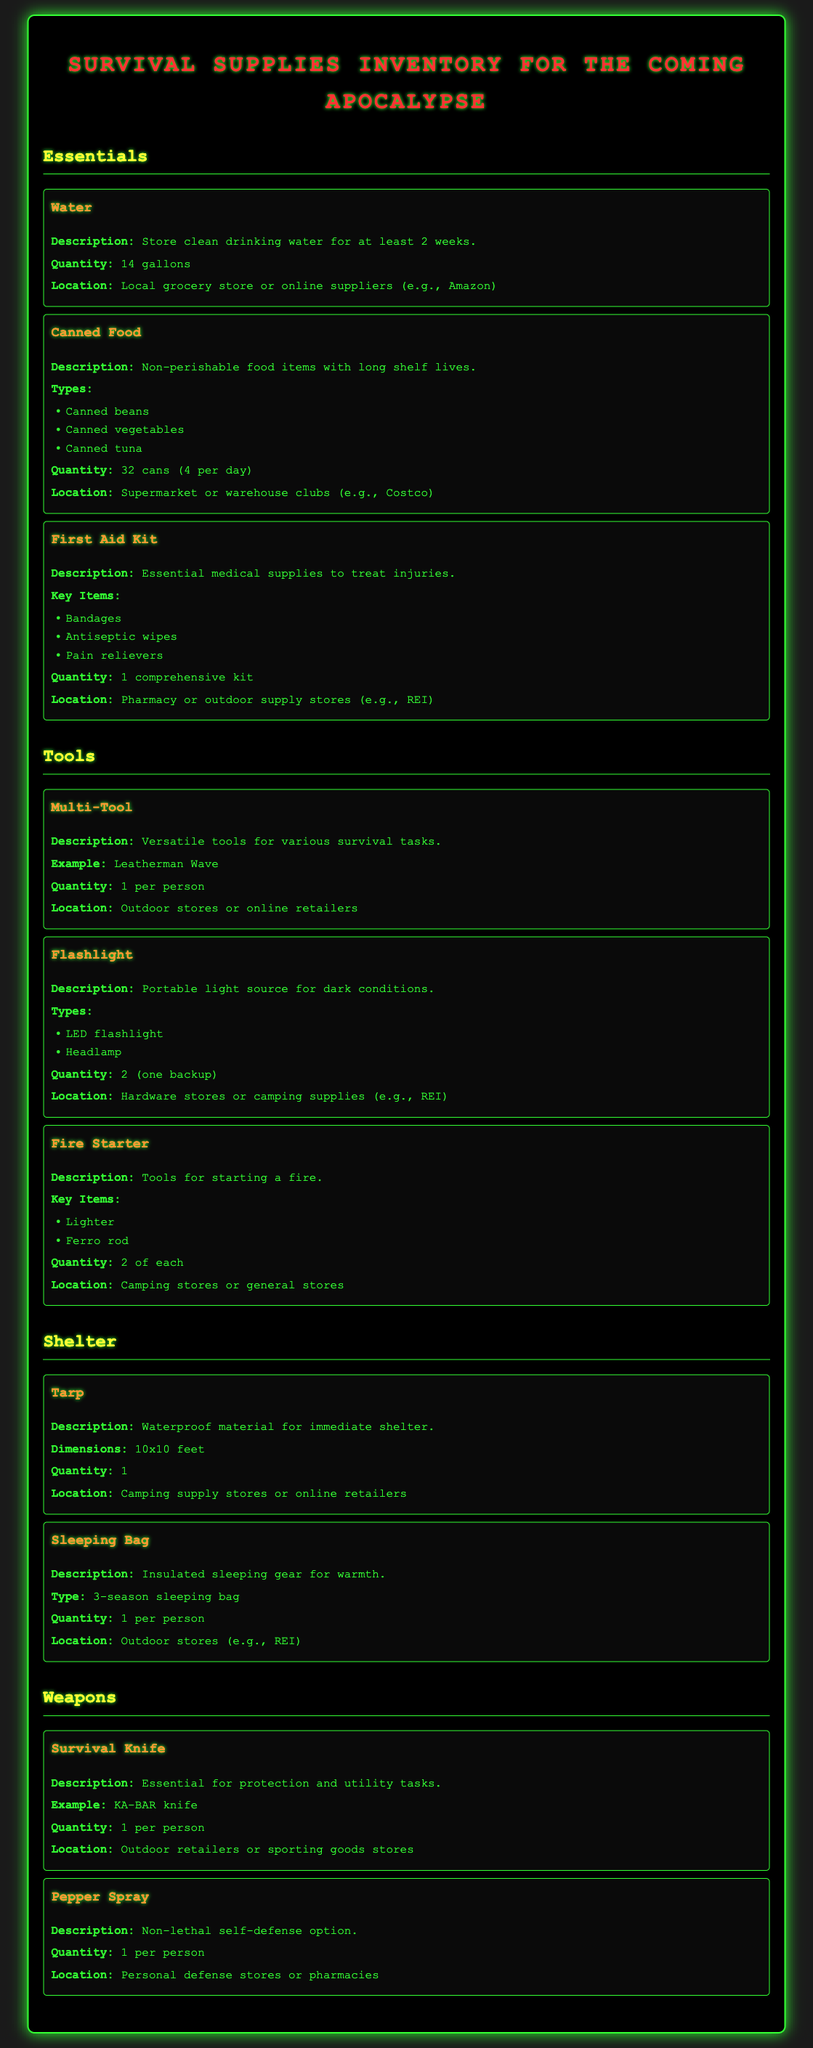what is the quantity of water? The document states that the quantity of water to store is 14 gallons.
Answer: 14 gallons how many cans of food are included? The total number of cans of food listed in the document is 32.
Answer: 32 cans where can I find a tarp? The document indicates that tarps can be found at camping supply stores or online retailers.
Answer: Camping supply stores or online retailers what is one key item in the first aid kit? The document mentions bandages as one of the key items in the first aid kit.
Answer: Bandages how many types of flashlights are listed? The document lists two types of flashlights: LED flashlight and headlamp.
Answer: 2 what is the example of a survival knife provided? The example of a survival knife mentioned in the document is a KA-BAR knife.
Answer: KA-BAR knife what is the description of canned food? Canned food is described as non-perishable food items with long shelf lives.
Answer: Non-perishable food items with long shelf lives how many fire starters should be included? The document specifies that 2 of each type of fire starter should be included.
Answer: 2 of each what is the type of sleeping bag recommended? The document suggests using a 3-season sleeping bag.
Answer: 3-season sleeping bag 